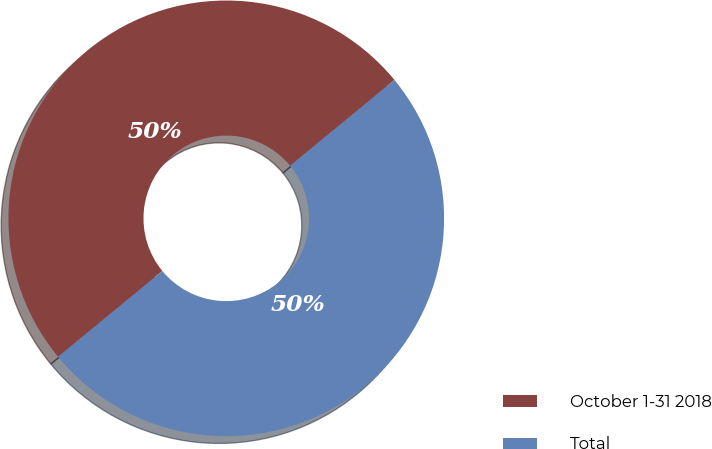Convert chart to OTSL. <chart><loc_0><loc_0><loc_500><loc_500><pie_chart><fcel>October 1-31 2018<fcel>Total<nl><fcel>50.0%<fcel>50.0%<nl></chart> 